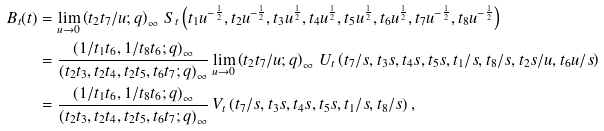Convert formula to latex. <formula><loc_0><loc_0><loc_500><loc_500>B _ { t } ( t ) & = \lim _ { u \rightarrow 0 } \left ( t _ { 2 } t _ { 7 } / u ; q \right ) _ { \infty } \, S _ { t } \left ( t _ { 1 } u ^ { - \frac { 1 } { 2 } } , t _ { 2 } u ^ { - \frac { 1 } { 2 } } , t _ { 3 } u ^ { \frac { 1 } { 2 } } , t _ { 4 } u ^ { \frac { 1 } { 2 } } , t _ { 5 } u ^ { \frac { 1 } { 2 } } , t _ { 6 } u ^ { \frac { 1 } { 2 } } , t _ { 7 } u ^ { - \frac { 1 } { 2 } } , t _ { 8 } u ^ { - \frac { 1 } { 2 } } \right ) \\ & = \frac { \left ( 1 / t _ { 1 } t _ { 6 } , 1 / t _ { 8 } t _ { 6 } ; q \right ) _ { \infty } } { \left ( t _ { 2 } t _ { 3 } , t _ { 2 } t _ { 4 } , t _ { 2 } t _ { 5 } , t _ { 6 } t _ { 7 } ; q \right ) _ { \infty } } \lim _ { u \rightarrow 0 } \left ( t _ { 2 } t _ { 7 } / u ; q \right ) _ { \infty } \, U _ { t } \left ( t _ { 7 } / s , t _ { 3 } s , t _ { 4 } s , t _ { 5 } s , t _ { 1 } / s , t _ { 8 } / s , t _ { 2 } s / u , t _ { 6 } u / s \right ) \\ & = \frac { \left ( 1 / t _ { 1 } t _ { 6 } , 1 / t _ { 8 } t _ { 6 } ; q \right ) _ { \infty } } { \left ( t _ { 2 } t _ { 3 } , t _ { 2 } t _ { 4 } , t _ { 2 } t _ { 5 } , t _ { 6 } t _ { 7 } ; q \right ) _ { \infty } } \, V _ { t } \left ( t _ { 7 } / s , t _ { 3 } s , t _ { 4 } s , t _ { 5 } s , t _ { 1 } / s , t _ { 8 } / s \right ) ,</formula> 